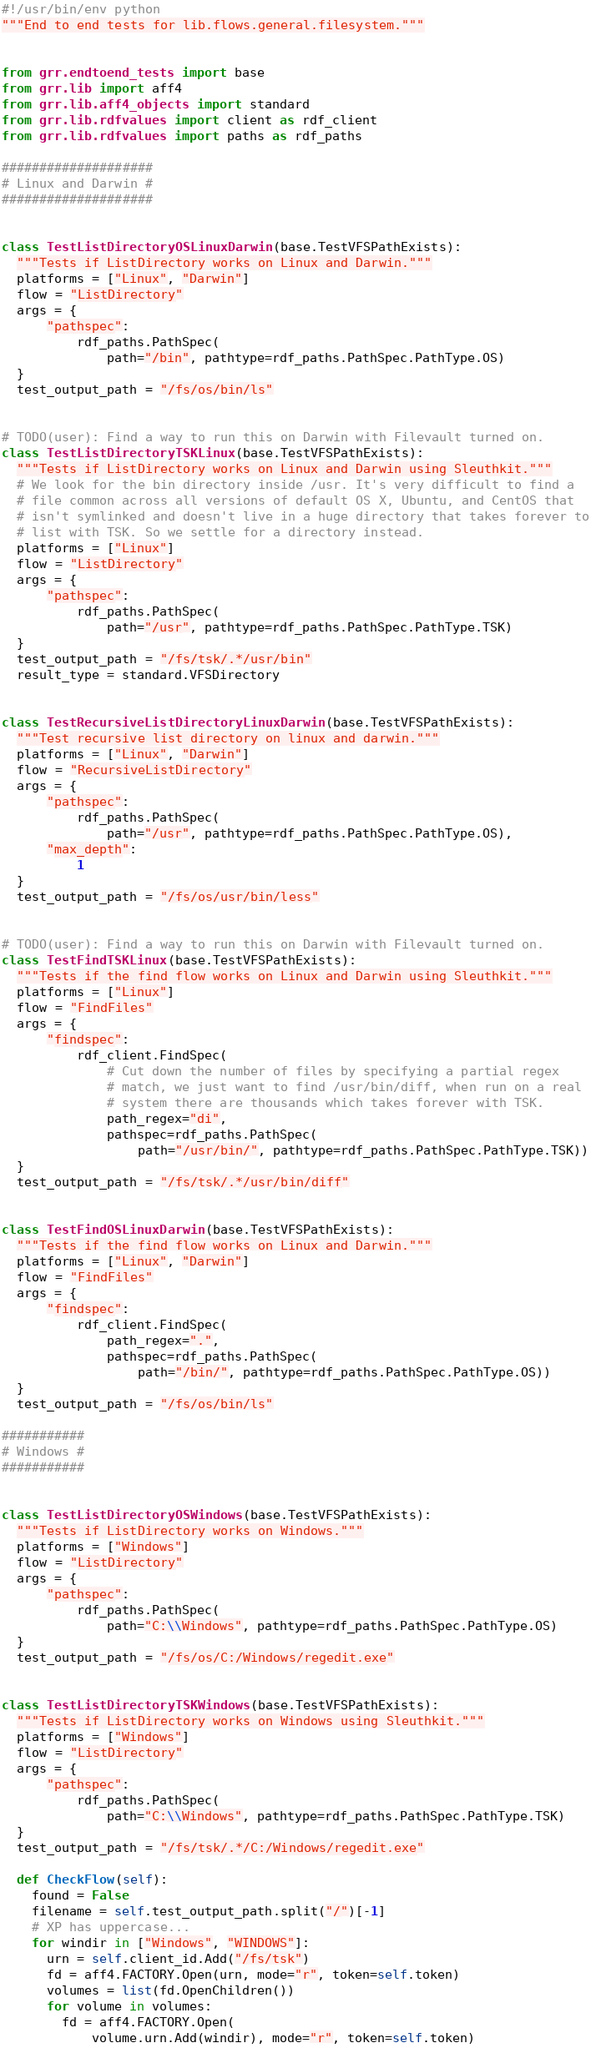<code> <loc_0><loc_0><loc_500><loc_500><_Python_>#!/usr/bin/env python
"""End to end tests for lib.flows.general.filesystem."""


from grr.endtoend_tests import base
from grr.lib import aff4
from grr.lib.aff4_objects import standard
from grr.lib.rdfvalues import client as rdf_client
from grr.lib.rdfvalues import paths as rdf_paths

####################
# Linux and Darwin #
####################


class TestListDirectoryOSLinuxDarwin(base.TestVFSPathExists):
  """Tests if ListDirectory works on Linux and Darwin."""
  platforms = ["Linux", "Darwin"]
  flow = "ListDirectory"
  args = {
      "pathspec":
          rdf_paths.PathSpec(
              path="/bin", pathtype=rdf_paths.PathSpec.PathType.OS)
  }
  test_output_path = "/fs/os/bin/ls"


# TODO(user): Find a way to run this on Darwin with Filevault turned on.
class TestListDirectoryTSKLinux(base.TestVFSPathExists):
  """Tests if ListDirectory works on Linux and Darwin using Sleuthkit."""
  # We look for the bin directory inside /usr. It's very difficult to find a
  # file common across all versions of default OS X, Ubuntu, and CentOS that
  # isn't symlinked and doesn't live in a huge directory that takes forever to
  # list with TSK. So we settle for a directory instead.
  platforms = ["Linux"]
  flow = "ListDirectory"
  args = {
      "pathspec":
          rdf_paths.PathSpec(
              path="/usr", pathtype=rdf_paths.PathSpec.PathType.TSK)
  }
  test_output_path = "/fs/tsk/.*/usr/bin"
  result_type = standard.VFSDirectory


class TestRecursiveListDirectoryLinuxDarwin(base.TestVFSPathExists):
  """Test recursive list directory on linux and darwin."""
  platforms = ["Linux", "Darwin"]
  flow = "RecursiveListDirectory"
  args = {
      "pathspec":
          rdf_paths.PathSpec(
              path="/usr", pathtype=rdf_paths.PathSpec.PathType.OS),
      "max_depth":
          1
  }
  test_output_path = "/fs/os/usr/bin/less"


# TODO(user): Find a way to run this on Darwin with Filevault turned on.
class TestFindTSKLinux(base.TestVFSPathExists):
  """Tests if the find flow works on Linux and Darwin using Sleuthkit."""
  platforms = ["Linux"]
  flow = "FindFiles"
  args = {
      "findspec":
          rdf_client.FindSpec(
              # Cut down the number of files by specifying a partial regex
              # match, we just want to find /usr/bin/diff, when run on a real
              # system there are thousands which takes forever with TSK.
              path_regex="di",
              pathspec=rdf_paths.PathSpec(
                  path="/usr/bin/", pathtype=rdf_paths.PathSpec.PathType.TSK))
  }
  test_output_path = "/fs/tsk/.*/usr/bin/diff"


class TestFindOSLinuxDarwin(base.TestVFSPathExists):
  """Tests if the find flow works on Linux and Darwin."""
  platforms = ["Linux", "Darwin"]
  flow = "FindFiles"
  args = {
      "findspec":
          rdf_client.FindSpec(
              path_regex=".",
              pathspec=rdf_paths.PathSpec(
                  path="/bin/", pathtype=rdf_paths.PathSpec.PathType.OS))
  }
  test_output_path = "/fs/os/bin/ls"

###########
# Windows #
###########


class TestListDirectoryOSWindows(base.TestVFSPathExists):
  """Tests if ListDirectory works on Windows."""
  platforms = ["Windows"]
  flow = "ListDirectory"
  args = {
      "pathspec":
          rdf_paths.PathSpec(
              path="C:\\Windows", pathtype=rdf_paths.PathSpec.PathType.OS)
  }
  test_output_path = "/fs/os/C:/Windows/regedit.exe"


class TestListDirectoryTSKWindows(base.TestVFSPathExists):
  """Tests if ListDirectory works on Windows using Sleuthkit."""
  platforms = ["Windows"]
  flow = "ListDirectory"
  args = {
      "pathspec":
          rdf_paths.PathSpec(
              path="C:\\Windows", pathtype=rdf_paths.PathSpec.PathType.TSK)
  }
  test_output_path = "/fs/tsk/.*/C:/Windows/regedit.exe"

  def CheckFlow(self):
    found = False
    filename = self.test_output_path.split("/")[-1]
    # XP has uppercase...
    for windir in ["Windows", "WINDOWS"]:
      urn = self.client_id.Add("/fs/tsk")
      fd = aff4.FACTORY.Open(urn, mode="r", token=self.token)
      volumes = list(fd.OpenChildren())
      for volume in volumes:
        fd = aff4.FACTORY.Open(
            volume.urn.Add(windir), mode="r", token=self.token)</code> 